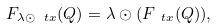Convert formula to latex. <formula><loc_0><loc_0><loc_500><loc_500>F _ { \lambda \odot \ t x } ( Q ) = \lambda \odot ( F _ { \ t x } ( Q ) ) ,</formula> 